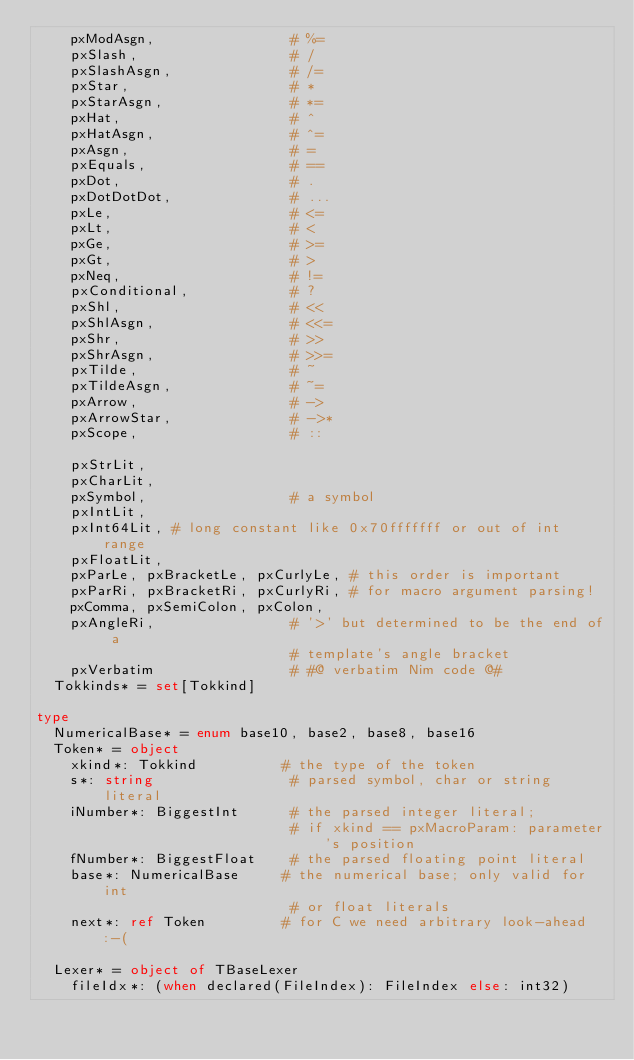<code> <loc_0><loc_0><loc_500><loc_500><_Nim_>    pxModAsgn,                # %=
    pxSlash,                  # /
    pxSlashAsgn,              # /=
    pxStar,                   # *
    pxStarAsgn,               # *=
    pxHat,                    # ^
    pxHatAsgn,                # ^=
    pxAsgn,                   # =
    pxEquals,                 # ==
    pxDot,                    # .
    pxDotDotDot,              # ...
    pxLe,                     # <=
    pxLt,                     # <
    pxGe,                     # >=
    pxGt,                     # >
    pxNeq,                    # !=
    pxConditional,            # ?
    pxShl,                    # <<
    pxShlAsgn,                # <<=
    pxShr,                    # >>
    pxShrAsgn,                # >>=
    pxTilde,                  # ~
    pxTildeAsgn,              # ~=
    pxArrow,                  # ->
    pxArrowStar,              # ->*
    pxScope,                  # ::

    pxStrLit,
    pxCharLit,
    pxSymbol,                 # a symbol
    pxIntLit,
    pxInt64Lit, # long constant like 0x70fffffff or out of int range
    pxFloatLit,
    pxParLe, pxBracketLe, pxCurlyLe, # this order is important
    pxParRi, pxBracketRi, pxCurlyRi, # for macro argument parsing!
    pxComma, pxSemiColon, pxColon,
    pxAngleRi,                # '>' but determined to be the end of a
                              # template's angle bracket
    pxVerbatim                # #@ verbatim Nim code @#
  Tokkinds* = set[Tokkind]

type
  NumericalBase* = enum base10, base2, base8, base16
  Token* = object
    xkind*: Tokkind          # the type of the token
    s*: string                # parsed symbol, char or string literal
    iNumber*: BiggestInt      # the parsed integer literal;
                              # if xkind == pxMacroParam: parameter's position
    fNumber*: BiggestFloat    # the parsed floating point literal
    base*: NumericalBase     # the numerical base; only valid for int
                              # or float literals
    next*: ref Token         # for C we need arbitrary look-ahead :-(

  Lexer* = object of TBaseLexer
    fileIdx*: (when declared(FileIndex): FileIndex else: int32)</code> 